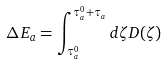Convert formula to latex. <formula><loc_0><loc_0><loc_500><loc_500>\Delta E _ { a } = \int _ { \tau _ { a } ^ { 0 } } ^ { \tau _ { a } ^ { 0 } + \tau _ { a } } d \zeta D ( \zeta )</formula> 